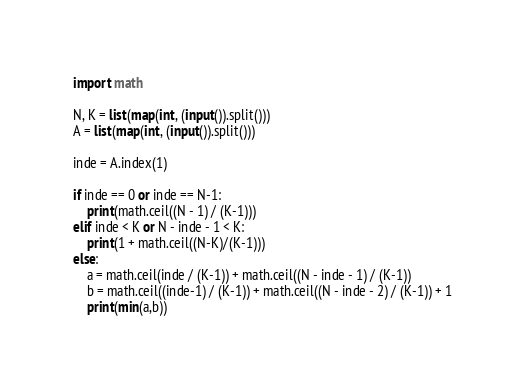Convert code to text. <code><loc_0><loc_0><loc_500><loc_500><_Python_>import math

N, K = list(map(int, (input()).split()))
A = list(map(int, (input()).split()))

inde = A.index(1)

if inde == 0 or inde == N-1:
	print(math.ceil((N - 1) / (K-1)))
elif inde < K or N - inde - 1 < K:
	print(1 + math.ceil((N-K)/(K-1)))
else:
	a = math.ceil(inde / (K-1)) + math.ceil((N - inde - 1) / (K-1))
	b = math.ceil((inde-1) / (K-1)) + math.ceil((N - inde - 2) / (K-1)) + 1
	print(min(a,b))</code> 